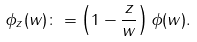Convert formula to latex. <formula><loc_0><loc_0><loc_500><loc_500>\phi _ { z } ( w ) \colon = \left ( 1 - \frac { z } { w } \right ) \phi ( w ) .</formula> 